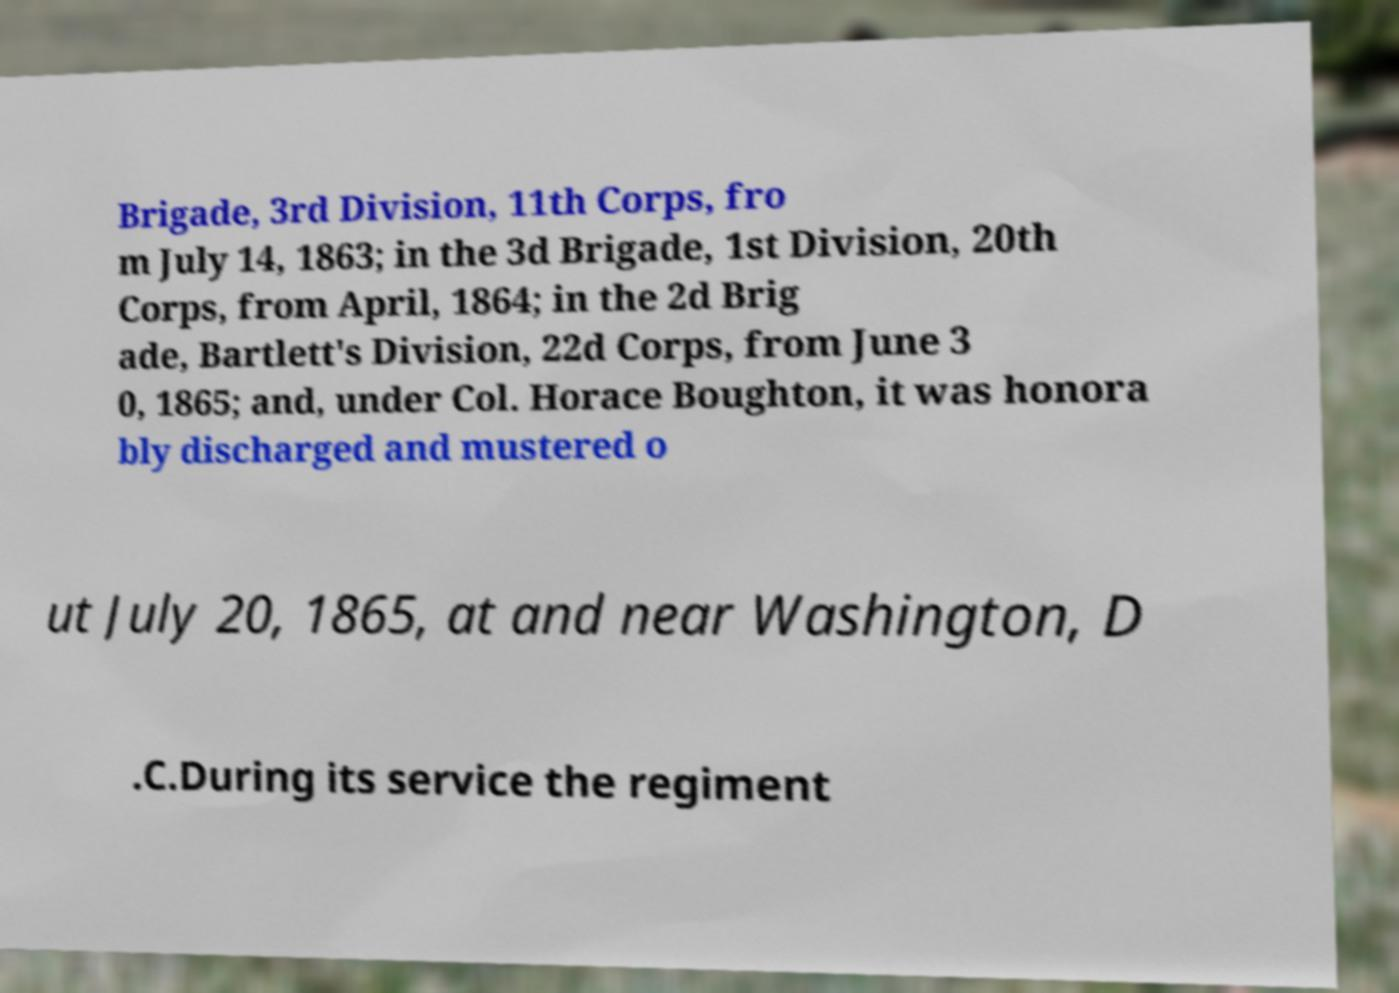There's text embedded in this image that I need extracted. Can you transcribe it verbatim? Brigade, 3rd Division, 11th Corps, fro m July 14, 1863; in the 3d Brigade, 1st Division, 20th Corps, from April, 1864; in the 2d Brig ade, Bartlett's Division, 22d Corps, from June 3 0, 1865; and, under Col. Horace Boughton, it was honora bly discharged and mustered o ut July 20, 1865, at and near Washington, D .C.During its service the regiment 